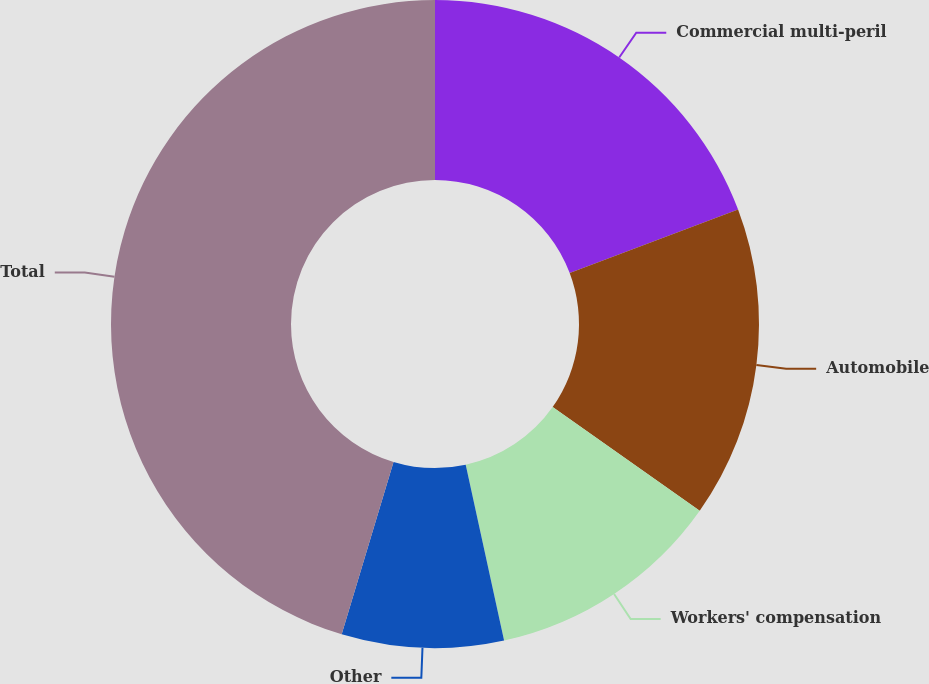Convert chart. <chart><loc_0><loc_0><loc_500><loc_500><pie_chart><fcel>Commercial multi-peril<fcel>Automobile<fcel>Workers' compensation<fcel>Other<fcel>Total<nl><fcel>19.25%<fcel>15.53%<fcel>11.8%<fcel>8.07%<fcel>45.35%<nl></chart> 